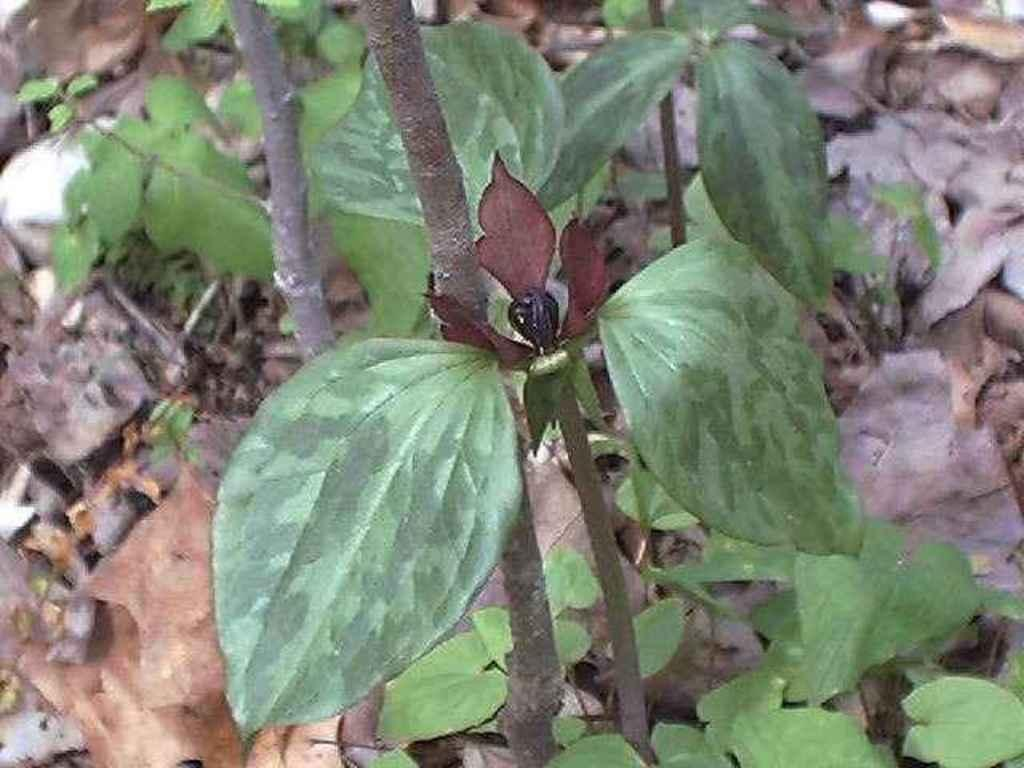What type of living organisms can be seen in the image? Plants can be seen in the image. What is a characteristic of the plants in the image? Dry leaves are present in the image. What advice does the minister give to the mother in the image? There is no mother or minister present in the image; it only features plants with dry leaves. 